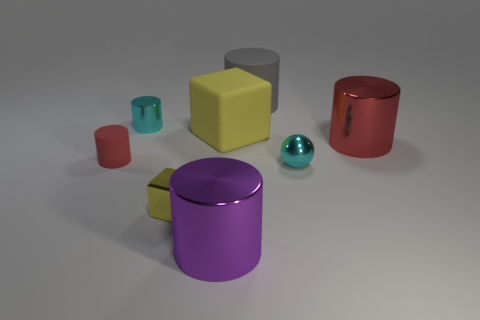Are there any tiny cylinders of the same color as the tiny rubber object?
Your answer should be compact. No. Is the number of yellow cubes that are on the left side of the cyan cylinder the same as the number of small purple matte cylinders?
Your response must be concise. Yes. Do the large rubber cube and the small metal cube have the same color?
Keep it short and to the point. Yes. There is a metal thing that is right of the small yellow metallic thing and in front of the tiny cyan ball; what size is it?
Keep it short and to the point. Large. There is a small sphere that is made of the same material as the big red object; what is its color?
Your answer should be compact. Cyan. What number of yellow objects are the same material as the gray object?
Offer a very short reply. 1. Are there the same number of large gray matte things right of the yellow rubber object and red metallic cylinders in front of the large red metallic object?
Give a very brief answer. No. There is a red rubber thing; is its shape the same as the cyan object on the left side of the large purple object?
Ensure brevity in your answer.  Yes. There is a object that is the same color as the shiny cube; what is its material?
Ensure brevity in your answer.  Rubber. Do the purple object and the yellow cube behind the red matte thing have the same material?
Ensure brevity in your answer.  No. 